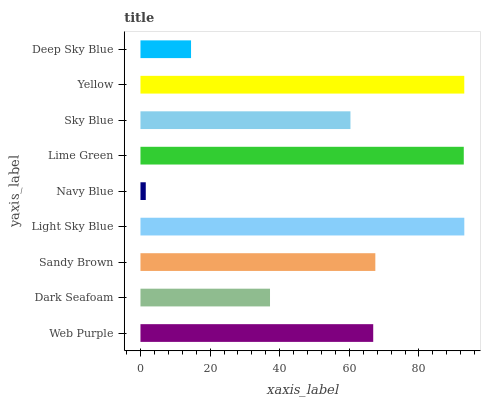Is Navy Blue the minimum?
Answer yes or no. Yes. Is Light Sky Blue the maximum?
Answer yes or no. Yes. Is Dark Seafoam the minimum?
Answer yes or no. No. Is Dark Seafoam the maximum?
Answer yes or no. No. Is Web Purple greater than Dark Seafoam?
Answer yes or no. Yes. Is Dark Seafoam less than Web Purple?
Answer yes or no. Yes. Is Dark Seafoam greater than Web Purple?
Answer yes or no. No. Is Web Purple less than Dark Seafoam?
Answer yes or no. No. Is Web Purple the high median?
Answer yes or no. Yes. Is Web Purple the low median?
Answer yes or no. Yes. Is Yellow the high median?
Answer yes or no. No. Is Yellow the low median?
Answer yes or no. No. 